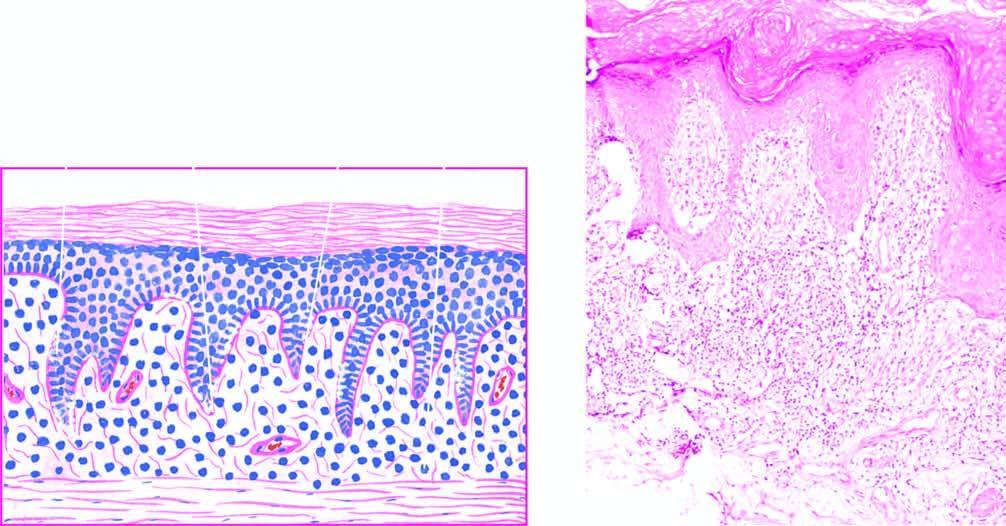how does the upper dermis show a band-like mononuclear infiltrate?
Answer the question using a single word or phrase. With a sharply-demarcated lower border 